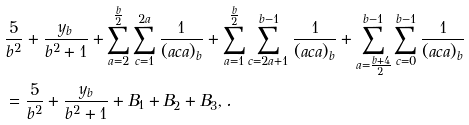Convert formula to latex. <formula><loc_0><loc_0><loc_500><loc_500>& \frac { 5 } { b ^ { 2 } } + \frac { y _ { b } } { b ^ { 2 } + 1 } + \sum _ { a = 2 } ^ { \frac { b } { 2 } } \sum _ { c = 1 } ^ { 2 a } \frac { 1 } { ( a c a ) _ { b } } + \sum _ { a = 1 } ^ { \frac { b } { 2 } } \sum _ { c = 2 a + 1 } ^ { b - 1 } \frac { 1 } { ( a c a ) _ { b } } + \sum _ { a = \frac { b + 4 } { 2 } } ^ { b - 1 } \sum _ { c = 0 } ^ { b - 1 } \frac { 1 } { ( a c a ) _ { b } } \\ & = \frac { 5 } { b ^ { 2 } } + \frac { y _ { b } } { b ^ { 2 } + 1 } + B _ { 1 } + B _ { 2 } + B _ { 3 } , .</formula> 